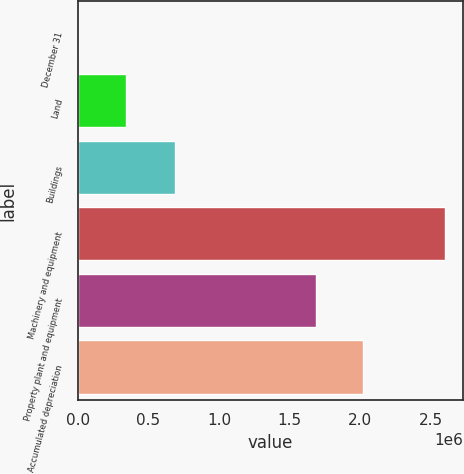Convert chart. <chart><loc_0><loc_0><loc_500><loc_500><bar_chart><fcel>December 31<fcel>Land<fcel>Buildings<fcel>Machinery and equipment<fcel>Property plant and equipment<fcel>Accumulated depreciation<nl><fcel>2004<fcel>338724<fcel>688642<fcel>2.596e+06<fcel>1.6827e+06<fcel>2.01942e+06<nl></chart> 